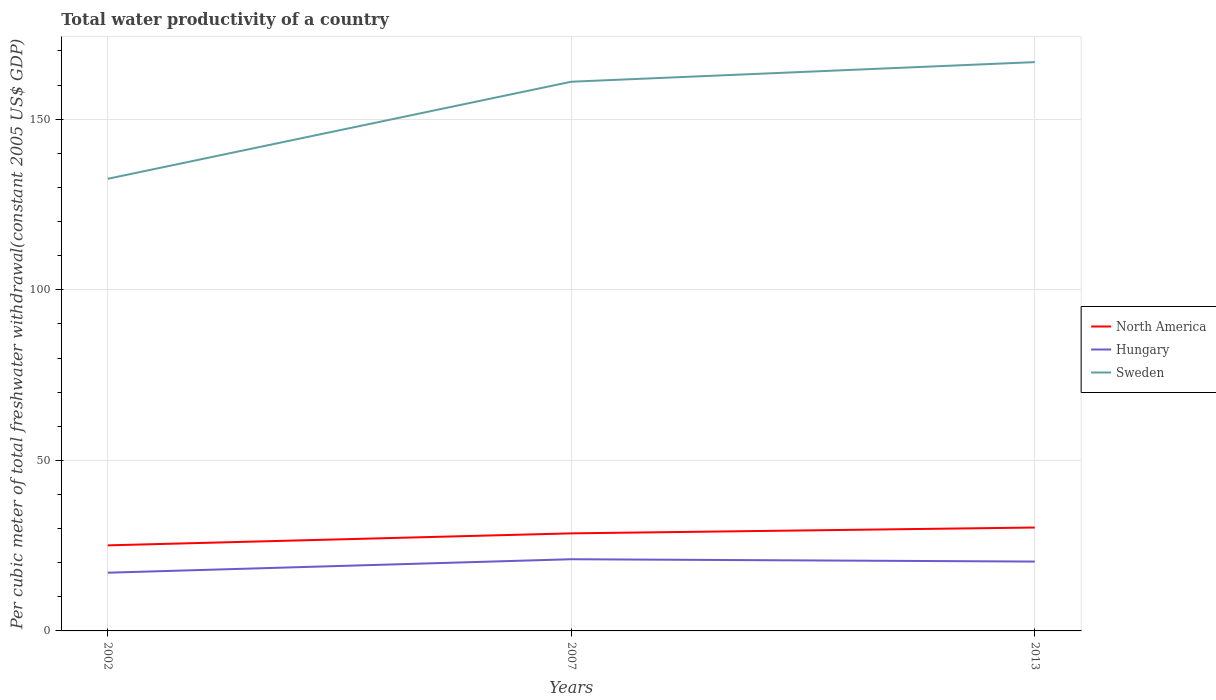Across all years, what is the maximum total water productivity in North America?
Offer a very short reply. 25.08. In which year was the total water productivity in Sweden maximum?
Your answer should be very brief. 2002. What is the total total water productivity in North America in the graph?
Give a very brief answer. -5.23. What is the difference between the highest and the second highest total water productivity in Sweden?
Make the answer very short. 34.21. What is the difference between the highest and the lowest total water productivity in North America?
Offer a very short reply. 2. Is the total water productivity in Sweden strictly greater than the total water productivity in Hungary over the years?
Ensure brevity in your answer.  No. How many years are there in the graph?
Make the answer very short. 3. Are the values on the major ticks of Y-axis written in scientific E-notation?
Offer a very short reply. No. Does the graph contain any zero values?
Your answer should be very brief. No. Does the graph contain grids?
Make the answer very short. Yes. How many legend labels are there?
Provide a succinct answer. 3. How are the legend labels stacked?
Provide a succinct answer. Vertical. What is the title of the graph?
Provide a short and direct response. Total water productivity of a country. Does "Morocco" appear as one of the legend labels in the graph?
Provide a short and direct response. No. What is the label or title of the X-axis?
Your answer should be compact. Years. What is the label or title of the Y-axis?
Keep it short and to the point. Per cubic meter of total freshwater withdrawal(constant 2005 US$ GDP). What is the Per cubic meter of total freshwater withdrawal(constant 2005 US$ GDP) of North America in 2002?
Offer a very short reply. 25.08. What is the Per cubic meter of total freshwater withdrawal(constant 2005 US$ GDP) of Hungary in 2002?
Make the answer very short. 17.06. What is the Per cubic meter of total freshwater withdrawal(constant 2005 US$ GDP) in Sweden in 2002?
Make the answer very short. 132.53. What is the Per cubic meter of total freshwater withdrawal(constant 2005 US$ GDP) of North America in 2007?
Give a very brief answer. 28.6. What is the Per cubic meter of total freshwater withdrawal(constant 2005 US$ GDP) in Hungary in 2007?
Provide a short and direct response. 21.01. What is the Per cubic meter of total freshwater withdrawal(constant 2005 US$ GDP) of Sweden in 2007?
Keep it short and to the point. 160.99. What is the Per cubic meter of total freshwater withdrawal(constant 2005 US$ GDP) of North America in 2013?
Keep it short and to the point. 30.31. What is the Per cubic meter of total freshwater withdrawal(constant 2005 US$ GDP) in Hungary in 2013?
Provide a short and direct response. 20.33. What is the Per cubic meter of total freshwater withdrawal(constant 2005 US$ GDP) in Sweden in 2013?
Ensure brevity in your answer.  166.74. Across all years, what is the maximum Per cubic meter of total freshwater withdrawal(constant 2005 US$ GDP) of North America?
Give a very brief answer. 30.31. Across all years, what is the maximum Per cubic meter of total freshwater withdrawal(constant 2005 US$ GDP) of Hungary?
Provide a succinct answer. 21.01. Across all years, what is the maximum Per cubic meter of total freshwater withdrawal(constant 2005 US$ GDP) in Sweden?
Make the answer very short. 166.74. Across all years, what is the minimum Per cubic meter of total freshwater withdrawal(constant 2005 US$ GDP) of North America?
Your response must be concise. 25.08. Across all years, what is the minimum Per cubic meter of total freshwater withdrawal(constant 2005 US$ GDP) of Hungary?
Give a very brief answer. 17.06. Across all years, what is the minimum Per cubic meter of total freshwater withdrawal(constant 2005 US$ GDP) of Sweden?
Give a very brief answer. 132.53. What is the total Per cubic meter of total freshwater withdrawal(constant 2005 US$ GDP) of North America in the graph?
Your answer should be very brief. 83.99. What is the total Per cubic meter of total freshwater withdrawal(constant 2005 US$ GDP) of Hungary in the graph?
Your response must be concise. 58.41. What is the total Per cubic meter of total freshwater withdrawal(constant 2005 US$ GDP) of Sweden in the graph?
Keep it short and to the point. 460.26. What is the difference between the Per cubic meter of total freshwater withdrawal(constant 2005 US$ GDP) in North America in 2002 and that in 2007?
Give a very brief answer. -3.52. What is the difference between the Per cubic meter of total freshwater withdrawal(constant 2005 US$ GDP) in Hungary in 2002 and that in 2007?
Your answer should be compact. -3.95. What is the difference between the Per cubic meter of total freshwater withdrawal(constant 2005 US$ GDP) of Sweden in 2002 and that in 2007?
Give a very brief answer. -28.46. What is the difference between the Per cubic meter of total freshwater withdrawal(constant 2005 US$ GDP) of North America in 2002 and that in 2013?
Your answer should be very brief. -5.23. What is the difference between the Per cubic meter of total freshwater withdrawal(constant 2005 US$ GDP) in Hungary in 2002 and that in 2013?
Make the answer very short. -3.27. What is the difference between the Per cubic meter of total freshwater withdrawal(constant 2005 US$ GDP) in Sweden in 2002 and that in 2013?
Provide a succinct answer. -34.21. What is the difference between the Per cubic meter of total freshwater withdrawal(constant 2005 US$ GDP) in North America in 2007 and that in 2013?
Provide a short and direct response. -1.71. What is the difference between the Per cubic meter of total freshwater withdrawal(constant 2005 US$ GDP) in Hungary in 2007 and that in 2013?
Ensure brevity in your answer.  0.68. What is the difference between the Per cubic meter of total freshwater withdrawal(constant 2005 US$ GDP) of Sweden in 2007 and that in 2013?
Ensure brevity in your answer.  -5.75. What is the difference between the Per cubic meter of total freshwater withdrawal(constant 2005 US$ GDP) in North America in 2002 and the Per cubic meter of total freshwater withdrawal(constant 2005 US$ GDP) in Hungary in 2007?
Provide a succinct answer. 4.07. What is the difference between the Per cubic meter of total freshwater withdrawal(constant 2005 US$ GDP) of North America in 2002 and the Per cubic meter of total freshwater withdrawal(constant 2005 US$ GDP) of Sweden in 2007?
Make the answer very short. -135.91. What is the difference between the Per cubic meter of total freshwater withdrawal(constant 2005 US$ GDP) of Hungary in 2002 and the Per cubic meter of total freshwater withdrawal(constant 2005 US$ GDP) of Sweden in 2007?
Provide a short and direct response. -143.93. What is the difference between the Per cubic meter of total freshwater withdrawal(constant 2005 US$ GDP) of North America in 2002 and the Per cubic meter of total freshwater withdrawal(constant 2005 US$ GDP) of Hungary in 2013?
Your answer should be very brief. 4.75. What is the difference between the Per cubic meter of total freshwater withdrawal(constant 2005 US$ GDP) in North America in 2002 and the Per cubic meter of total freshwater withdrawal(constant 2005 US$ GDP) in Sweden in 2013?
Provide a succinct answer. -141.66. What is the difference between the Per cubic meter of total freshwater withdrawal(constant 2005 US$ GDP) of Hungary in 2002 and the Per cubic meter of total freshwater withdrawal(constant 2005 US$ GDP) of Sweden in 2013?
Provide a short and direct response. -149.68. What is the difference between the Per cubic meter of total freshwater withdrawal(constant 2005 US$ GDP) of North America in 2007 and the Per cubic meter of total freshwater withdrawal(constant 2005 US$ GDP) of Hungary in 2013?
Provide a short and direct response. 8.27. What is the difference between the Per cubic meter of total freshwater withdrawal(constant 2005 US$ GDP) of North America in 2007 and the Per cubic meter of total freshwater withdrawal(constant 2005 US$ GDP) of Sweden in 2013?
Offer a terse response. -138.14. What is the difference between the Per cubic meter of total freshwater withdrawal(constant 2005 US$ GDP) of Hungary in 2007 and the Per cubic meter of total freshwater withdrawal(constant 2005 US$ GDP) of Sweden in 2013?
Offer a terse response. -145.73. What is the average Per cubic meter of total freshwater withdrawal(constant 2005 US$ GDP) of North America per year?
Make the answer very short. 28. What is the average Per cubic meter of total freshwater withdrawal(constant 2005 US$ GDP) of Hungary per year?
Offer a very short reply. 19.47. What is the average Per cubic meter of total freshwater withdrawal(constant 2005 US$ GDP) in Sweden per year?
Provide a short and direct response. 153.42. In the year 2002, what is the difference between the Per cubic meter of total freshwater withdrawal(constant 2005 US$ GDP) of North America and Per cubic meter of total freshwater withdrawal(constant 2005 US$ GDP) of Hungary?
Offer a very short reply. 8.02. In the year 2002, what is the difference between the Per cubic meter of total freshwater withdrawal(constant 2005 US$ GDP) in North America and Per cubic meter of total freshwater withdrawal(constant 2005 US$ GDP) in Sweden?
Ensure brevity in your answer.  -107.45. In the year 2002, what is the difference between the Per cubic meter of total freshwater withdrawal(constant 2005 US$ GDP) of Hungary and Per cubic meter of total freshwater withdrawal(constant 2005 US$ GDP) of Sweden?
Offer a very short reply. -115.47. In the year 2007, what is the difference between the Per cubic meter of total freshwater withdrawal(constant 2005 US$ GDP) in North America and Per cubic meter of total freshwater withdrawal(constant 2005 US$ GDP) in Hungary?
Keep it short and to the point. 7.59. In the year 2007, what is the difference between the Per cubic meter of total freshwater withdrawal(constant 2005 US$ GDP) of North America and Per cubic meter of total freshwater withdrawal(constant 2005 US$ GDP) of Sweden?
Your response must be concise. -132.39. In the year 2007, what is the difference between the Per cubic meter of total freshwater withdrawal(constant 2005 US$ GDP) in Hungary and Per cubic meter of total freshwater withdrawal(constant 2005 US$ GDP) in Sweden?
Your response must be concise. -139.98. In the year 2013, what is the difference between the Per cubic meter of total freshwater withdrawal(constant 2005 US$ GDP) in North America and Per cubic meter of total freshwater withdrawal(constant 2005 US$ GDP) in Hungary?
Your answer should be very brief. 9.98. In the year 2013, what is the difference between the Per cubic meter of total freshwater withdrawal(constant 2005 US$ GDP) of North America and Per cubic meter of total freshwater withdrawal(constant 2005 US$ GDP) of Sweden?
Provide a succinct answer. -136.43. In the year 2013, what is the difference between the Per cubic meter of total freshwater withdrawal(constant 2005 US$ GDP) in Hungary and Per cubic meter of total freshwater withdrawal(constant 2005 US$ GDP) in Sweden?
Provide a short and direct response. -146.41. What is the ratio of the Per cubic meter of total freshwater withdrawal(constant 2005 US$ GDP) of North America in 2002 to that in 2007?
Make the answer very short. 0.88. What is the ratio of the Per cubic meter of total freshwater withdrawal(constant 2005 US$ GDP) in Hungary in 2002 to that in 2007?
Ensure brevity in your answer.  0.81. What is the ratio of the Per cubic meter of total freshwater withdrawal(constant 2005 US$ GDP) in Sweden in 2002 to that in 2007?
Offer a terse response. 0.82. What is the ratio of the Per cubic meter of total freshwater withdrawal(constant 2005 US$ GDP) in North America in 2002 to that in 2013?
Ensure brevity in your answer.  0.83. What is the ratio of the Per cubic meter of total freshwater withdrawal(constant 2005 US$ GDP) in Hungary in 2002 to that in 2013?
Provide a succinct answer. 0.84. What is the ratio of the Per cubic meter of total freshwater withdrawal(constant 2005 US$ GDP) in Sweden in 2002 to that in 2013?
Ensure brevity in your answer.  0.79. What is the ratio of the Per cubic meter of total freshwater withdrawal(constant 2005 US$ GDP) of North America in 2007 to that in 2013?
Your answer should be very brief. 0.94. What is the ratio of the Per cubic meter of total freshwater withdrawal(constant 2005 US$ GDP) of Hungary in 2007 to that in 2013?
Keep it short and to the point. 1.03. What is the ratio of the Per cubic meter of total freshwater withdrawal(constant 2005 US$ GDP) in Sweden in 2007 to that in 2013?
Offer a very short reply. 0.97. What is the difference between the highest and the second highest Per cubic meter of total freshwater withdrawal(constant 2005 US$ GDP) of North America?
Offer a very short reply. 1.71. What is the difference between the highest and the second highest Per cubic meter of total freshwater withdrawal(constant 2005 US$ GDP) of Hungary?
Make the answer very short. 0.68. What is the difference between the highest and the second highest Per cubic meter of total freshwater withdrawal(constant 2005 US$ GDP) in Sweden?
Provide a succinct answer. 5.75. What is the difference between the highest and the lowest Per cubic meter of total freshwater withdrawal(constant 2005 US$ GDP) in North America?
Keep it short and to the point. 5.23. What is the difference between the highest and the lowest Per cubic meter of total freshwater withdrawal(constant 2005 US$ GDP) of Hungary?
Your response must be concise. 3.95. What is the difference between the highest and the lowest Per cubic meter of total freshwater withdrawal(constant 2005 US$ GDP) in Sweden?
Ensure brevity in your answer.  34.21. 